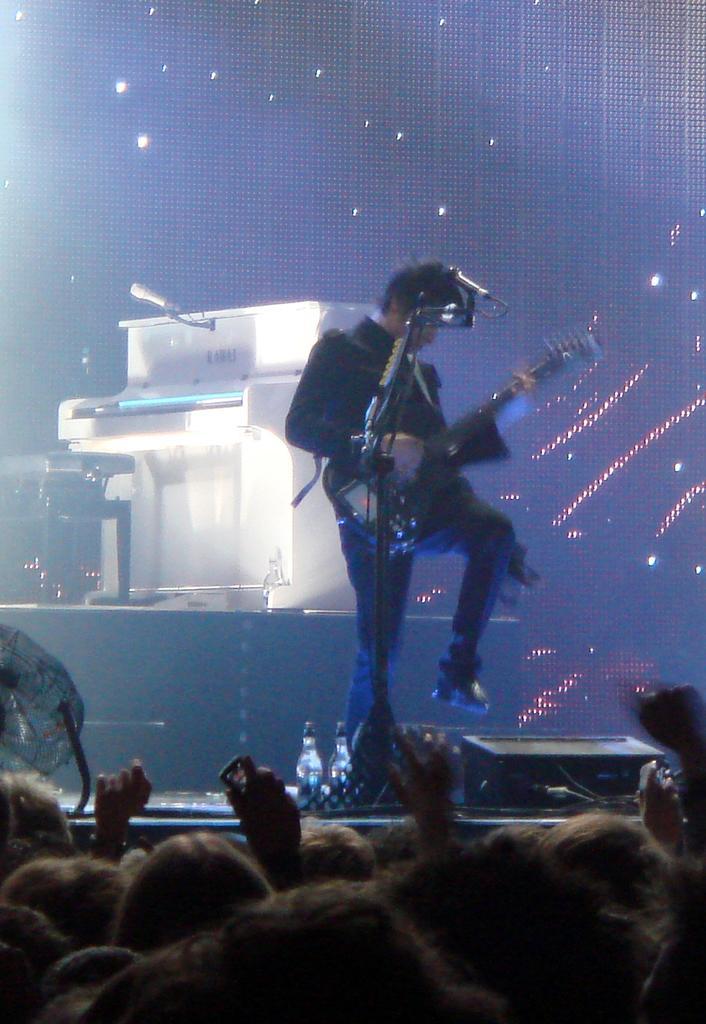Can you describe this image briefly? In this picture I can see a man standing and holding a guitar, there is a digital piano, a stool, there are mikes, bottles, there are group of people and there are some other objects, and in the background it is looking like a screen. 